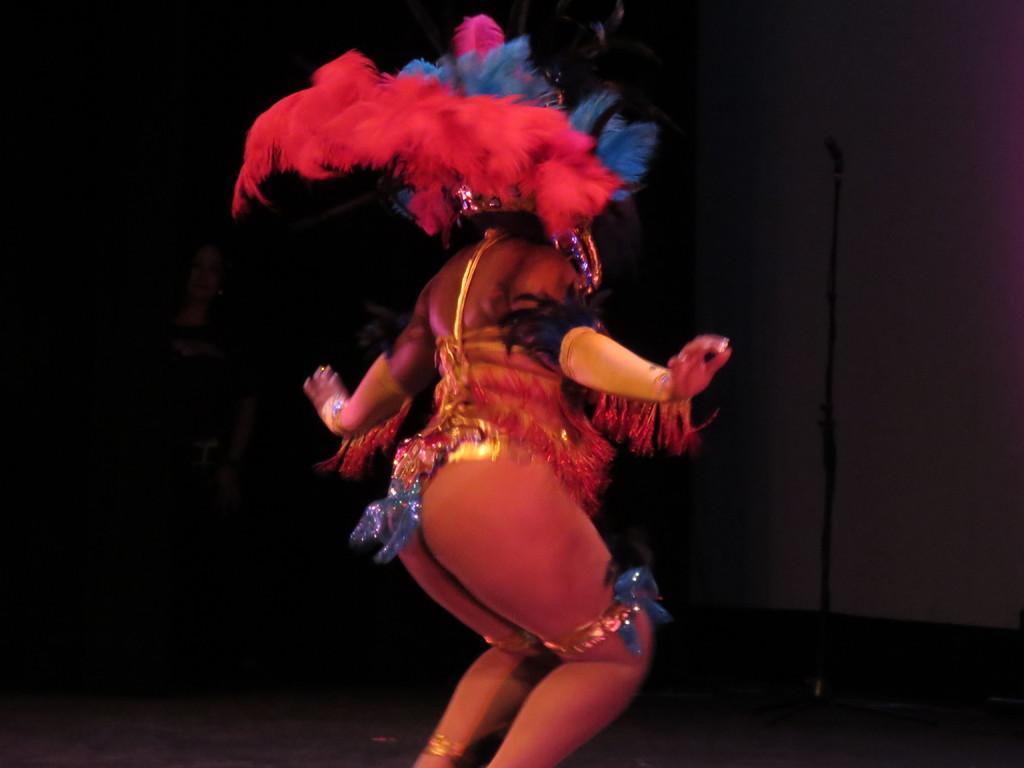Please provide a concise description of this image. In this image, at the middle there is a woman dancing, at the right side there is a microphone. 